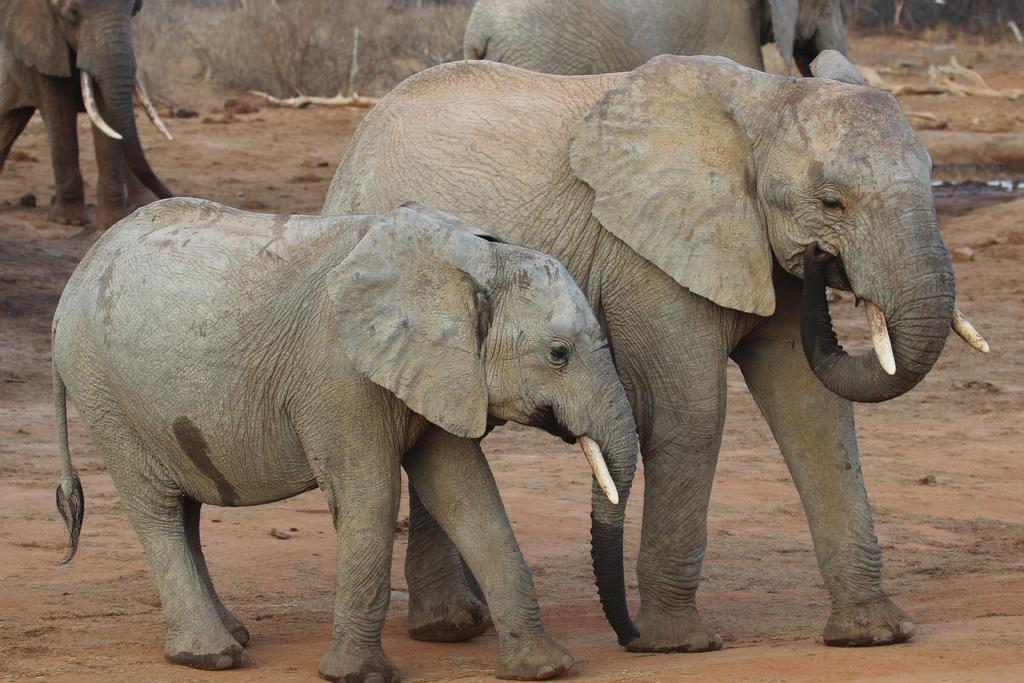How many elephants are present in the image? There are four elephants in the image. What color are the elephants? The elephants are cement in color. What type of terrain can be seen in the image? There is sand visible in the image. What type of drink is being served in the image? There is no drink present in the image; it features four cement-colored elephants and sand. What type of container is used to hold the quiver in the image? There is no quiver present in the image. 